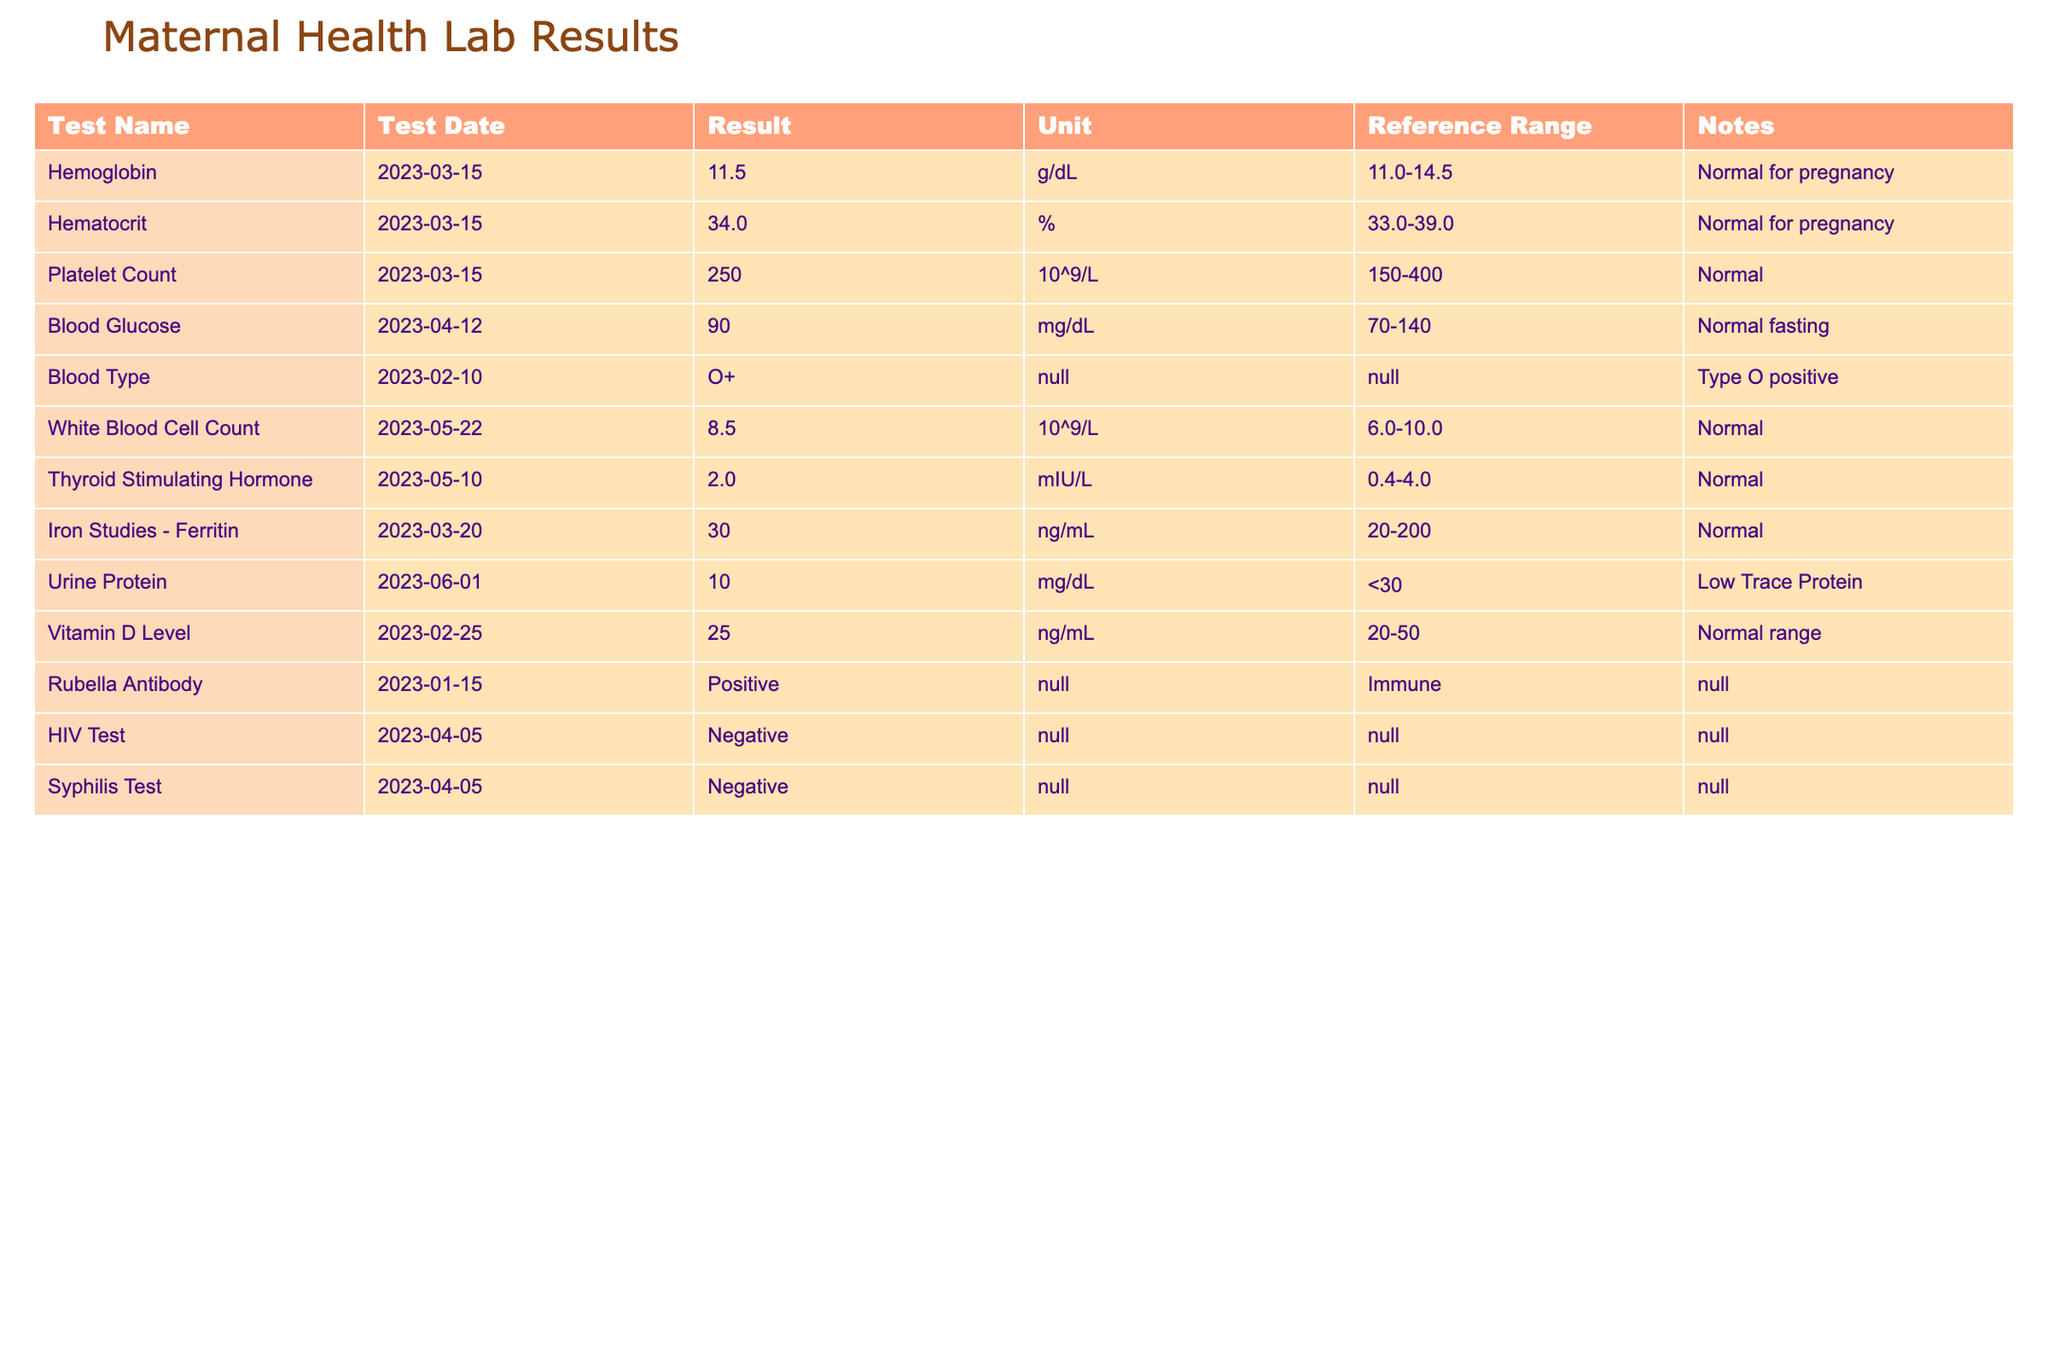What is the result for the Hemoglobin test? The Hemoglobin test result is listed in the table under the Result column for the date March 15, 2023. It shows a value of 11.5 g/dL.
Answer: 11.5 g/dL What is the reference range for platelet count? The reference range for platelet count is provided in the table under the Reference Range column. For this test, it is stated as 150-400 10^9/L.
Answer: 150-400 10^9/L Is the Blood Glucose result considered normal? The Blood Glucose result of 90 mg/dL is found under the Result column, and it is within the reference range of 70-140 mg/dL indicated for normal fasting levels, confirming it is normal.
Answer: Yes What is the difference between the Hematocrit and Thyroid Stimulating Hormone results? The Hematocrit result is 34.0%, and it can be found under the Result column for the date March 15, 2023. The Thyroid Stimulating Hormone is 2.0 mIU/L, found under its respective row on May 10, 2023. The difference can be calculated as 34.0 - 2.0 = 32.0.
Answer: 32.0 What are the results for the Urine Protein test? The Urine Protein test result is listed under the Result column for June 1, 2023, showing a value of 10 mg/dL, which is low trace protein according to the notes.
Answer: 10 mg/dL What percentage of the tests in the table fall within the normal reference range? There are 10 tests listed in the table. Out of these, all tests have results marked as normal except for the Urine Protein, which is noted as low trace protein. Thus, 9 out of 10 are normal, which calculates to (9/10)*100 = 90%.
Answer: 90% 